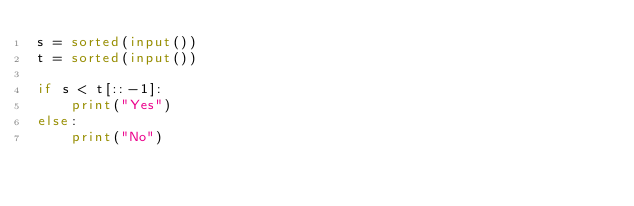Convert code to text. <code><loc_0><loc_0><loc_500><loc_500><_Python_>s = sorted(input())
t = sorted(input())

if s < t[::-1]:
    print("Yes")
else:
    print("No")</code> 